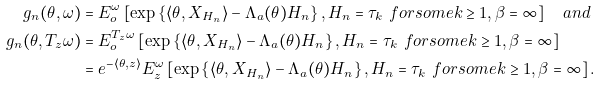<formula> <loc_0><loc_0><loc_500><loc_500>g _ { n } ( \theta , \omega ) & = E _ { o } ^ { \omega } \left [ \exp \left \{ \langle \theta , X _ { H _ { n } } \rangle - \Lambda _ { a } ( \theta ) H _ { n } \right \} , H _ { n } = \tau _ { k } \ f o r s o m e k \geq 1 , \beta = \infty \right ] \quad a n d \\ g _ { n } ( \theta , T _ { z } \omega ) & = E _ { o } ^ { T _ { z } \omega } \left [ \exp \left \{ \langle \theta , X _ { H _ { n } } \rangle - \Lambda _ { a } ( \theta ) H _ { n } \right \} , H _ { n } = \tau _ { k } \ f o r s o m e k \geq 1 , \beta = \infty \right ] \\ & = e ^ { - \langle \theta , z \rangle } E _ { z } ^ { \omega } \left [ \exp \left \{ \langle \theta , X _ { H _ { n } } \rangle - \Lambda _ { a } ( \theta ) H _ { n } \right \} , H _ { n } = \tau _ { k } \ f o r s o m e k \geq 1 , \beta = \infty \right ] .</formula> 